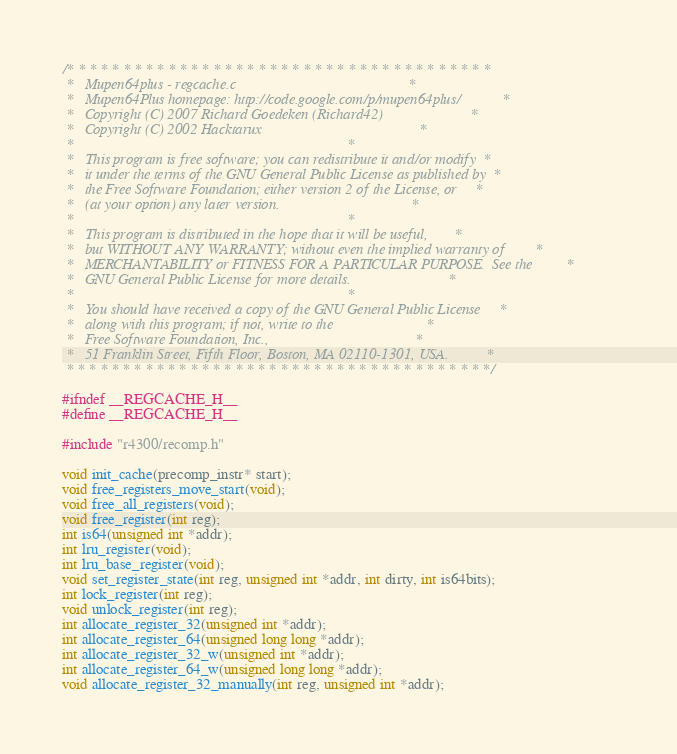Convert code to text. <code><loc_0><loc_0><loc_500><loc_500><_C_>/* * * * * * * * * * * * * * * * * * * * * * * * * * * * * * * * * * * * * *
 *   Mupen64plus - regcache.c                                              *
 *   Mupen64Plus homepage: http://code.google.com/p/mupen64plus/           *
 *   Copyright (C) 2007 Richard Goedeken (Richard42)                       *
 *   Copyright (C) 2002 Hacktarux                                          *
 *                                                                         *
 *   This program is free software; you can redistribute it and/or modify  *
 *   it under the terms of the GNU General Public License as published by  *
 *   the Free Software Foundation; either version 2 of the License, or     *
 *   (at your option) any later version.                                   *
 *                                                                         *
 *   This program is distributed in the hope that it will be useful,       *
 *   but WITHOUT ANY WARRANTY; without even the implied warranty of        *
 *   MERCHANTABILITY or FITNESS FOR A PARTICULAR PURPOSE.  See the         *
 *   GNU General Public License for more details.                          *
 *                                                                         *
 *   You should have received a copy of the GNU General Public License     *
 *   along with this program; if not, write to the                         *
 *   Free Software Foundation, Inc.,                                       *
 *   51 Franklin Street, Fifth Floor, Boston, MA 02110-1301, USA.          *
 * * * * * * * * * * * * * * * * * * * * * * * * * * * * * * * * * * * * * */

#ifndef __REGCACHE_H__
#define __REGCACHE_H__

#include "r4300/recomp.h"

void init_cache(precomp_instr* start);
void free_registers_move_start(void);
void free_all_registers(void);
void free_register(int reg);
int is64(unsigned int *addr);
int lru_register(void);
int lru_base_register(void);
void set_register_state(int reg, unsigned int *addr, int dirty, int is64bits);
int lock_register(int reg);
void unlock_register(int reg);
int allocate_register_32(unsigned int *addr);
int allocate_register_64(unsigned long long *addr);
int allocate_register_32_w(unsigned int *addr);
int allocate_register_64_w(unsigned long long *addr);
void allocate_register_32_manually(int reg, unsigned int *addr);</code> 